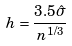Convert formula to latex. <formula><loc_0><loc_0><loc_500><loc_500>h = \frac { 3 . 5 \hat { \sigma } } { n ^ { 1 / 3 } }</formula> 